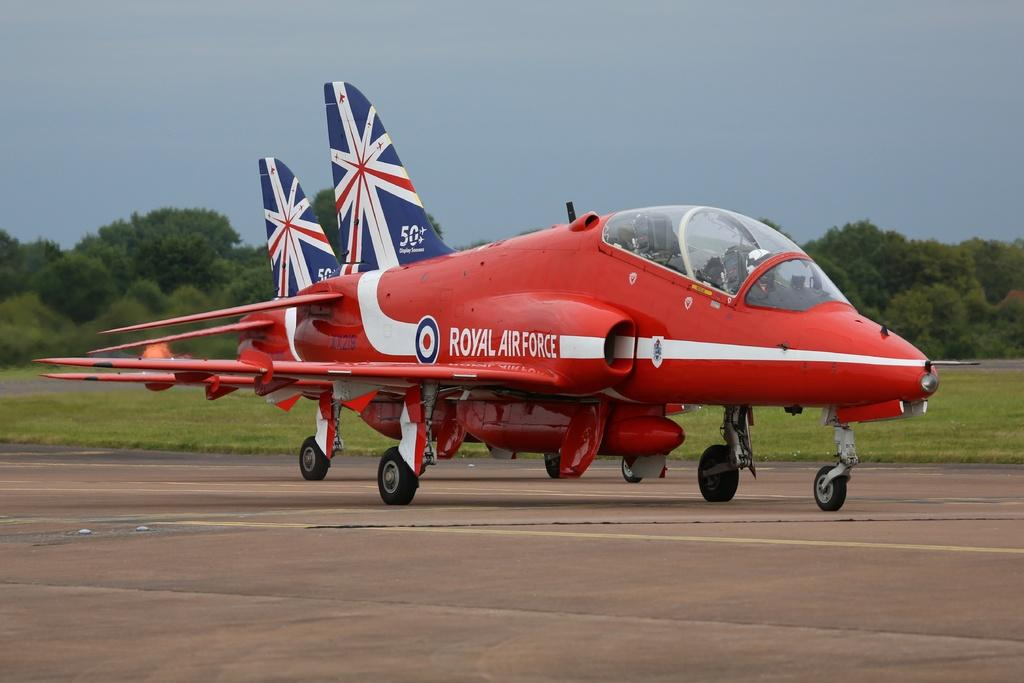What color is the airplane in the image? The airplane in the image is red. Where is the airplane located in the image? The airplane is on the road. What type of vegetation can be seen in the image? There are trees visible in the image. Where are the trees located in the image? The trees are on a grassland. What is visible in the background of the image? The sky is visible in the image. Can you see a horse in space in the image? No, there is no horse in space visible in the image. 